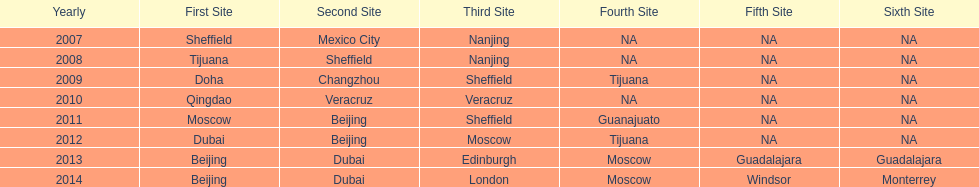Which is the only year that mexico is on a venue 2007. 